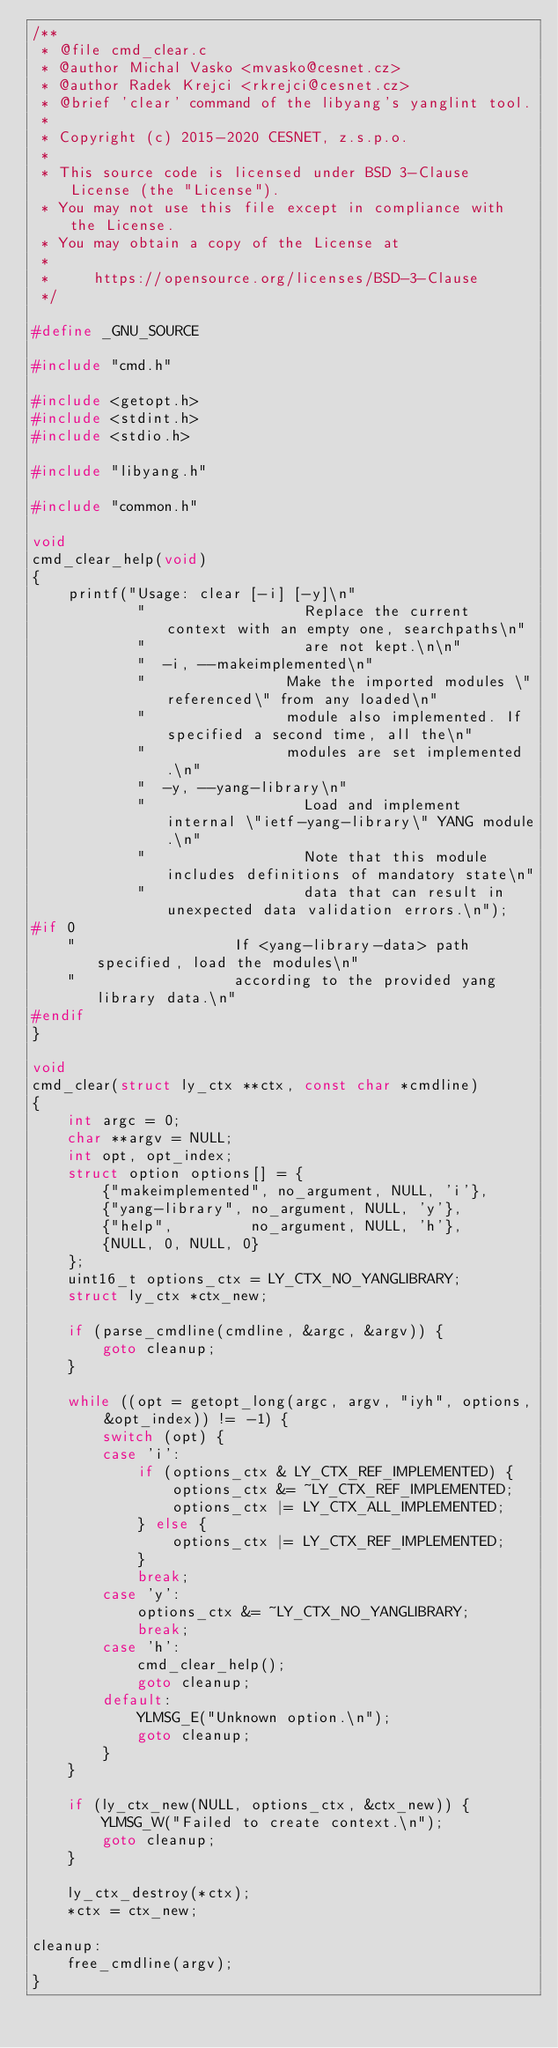<code> <loc_0><loc_0><loc_500><loc_500><_C_>/**
 * @file cmd_clear.c
 * @author Michal Vasko <mvasko@cesnet.cz>
 * @author Radek Krejci <rkrejci@cesnet.cz>
 * @brief 'clear' command of the libyang's yanglint tool.
 *
 * Copyright (c) 2015-2020 CESNET, z.s.p.o.
 *
 * This source code is licensed under BSD 3-Clause License (the "License").
 * You may not use this file except in compliance with the License.
 * You may obtain a copy of the License at
 *
 *     https://opensource.org/licenses/BSD-3-Clause
 */

#define _GNU_SOURCE

#include "cmd.h"

#include <getopt.h>
#include <stdint.h>
#include <stdio.h>

#include "libyang.h"

#include "common.h"

void
cmd_clear_help(void)
{
    printf("Usage: clear [-i] [-y]\n"
            "                  Replace the current context with an empty one, searchpaths\n"
            "                  are not kept.\n\n"
            "  -i, --makeimplemented\n"
            "                Make the imported modules \"referenced\" from any loaded\n"
            "                module also implemented. If specified a second time, all the\n"
            "                modules are set implemented.\n"
            "  -y, --yang-library\n"
            "                  Load and implement internal \"ietf-yang-library\" YANG module.\n"
            "                  Note that this module includes definitions of mandatory state\n"
            "                  data that can result in unexpected data validation errors.\n");
#if 0
    "                  If <yang-library-data> path specified, load the modules\n"
    "                  according to the provided yang library data.\n"
#endif
}

void
cmd_clear(struct ly_ctx **ctx, const char *cmdline)
{
    int argc = 0;
    char **argv = NULL;
    int opt, opt_index;
    struct option options[] = {
        {"makeimplemented", no_argument, NULL, 'i'},
        {"yang-library", no_argument, NULL, 'y'},
        {"help",         no_argument, NULL, 'h'},
        {NULL, 0, NULL, 0}
    };
    uint16_t options_ctx = LY_CTX_NO_YANGLIBRARY;
    struct ly_ctx *ctx_new;

    if (parse_cmdline(cmdline, &argc, &argv)) {
        goto cleanup;
    }

    while ((opt = getopt_long(argc, argv, "iyh", options, &opt_index)) != -1) {
        switch (opt) {
        case 'i':
            if (options_ctx & LY_CTX_REF_IMPLEMENTED) {
                options_ctx &= ~LY_CTX_REF_IMPLEMENTED;
                options_ctx |= LY_CTX_ALL_IMPLEMENTED;
            } else {
                options_ctx |= LY_CTX_REF_IMPLEMENTED;
            }
            break;
        case 'y':
            options_ctx &= ~LY_CTX_NO_YANGLIBRARY;
            break;
        case 'h':
            cmd_clear_help();
            goto cleanup;
        default:
            YLMSG_E("Unknown option.\n");
            goto cleanup;
        }
    }

    if (ly_ctx_new(NULL, options_ctx, &ctx_new)) {
        YLMSG_W("Failed to create context.\n");
        goto cleanup;
    }

    ly_ctx_destroy(*ctx);
    *ctx = ctx_new;

cleanup:
    free_cmdline(argv);
}
</code> 